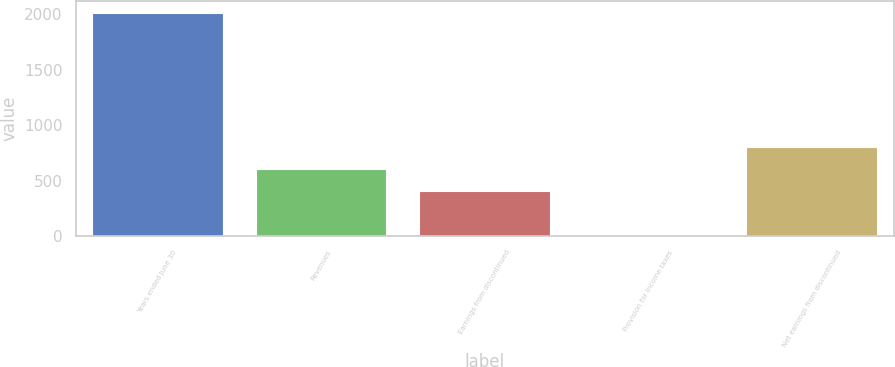Convert chart. <chart><loc_0><loc_0><loc_500><loc_500><bar_chart><fcel>Years ended June 30<fcel>Revenues<fcel>Earnings from discontinued<fcel>Provision for income taxes<fcel>Net earnings from discontinued<nl><fcel>2014<fcel>604.97<fcel>403.68<fcel>1.1<fcel>806.26<nl></chart> 